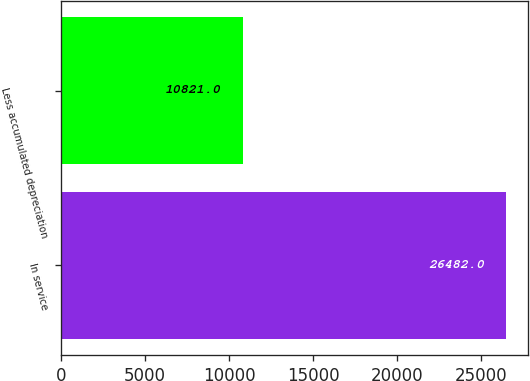<chart> <loc_0><loc_0><loc_500><loc_500><bar_chart><fcel>In service<fcel>Less accumulated depreciation<nl><fcel>26482<fcel>10821<nl></chart> 